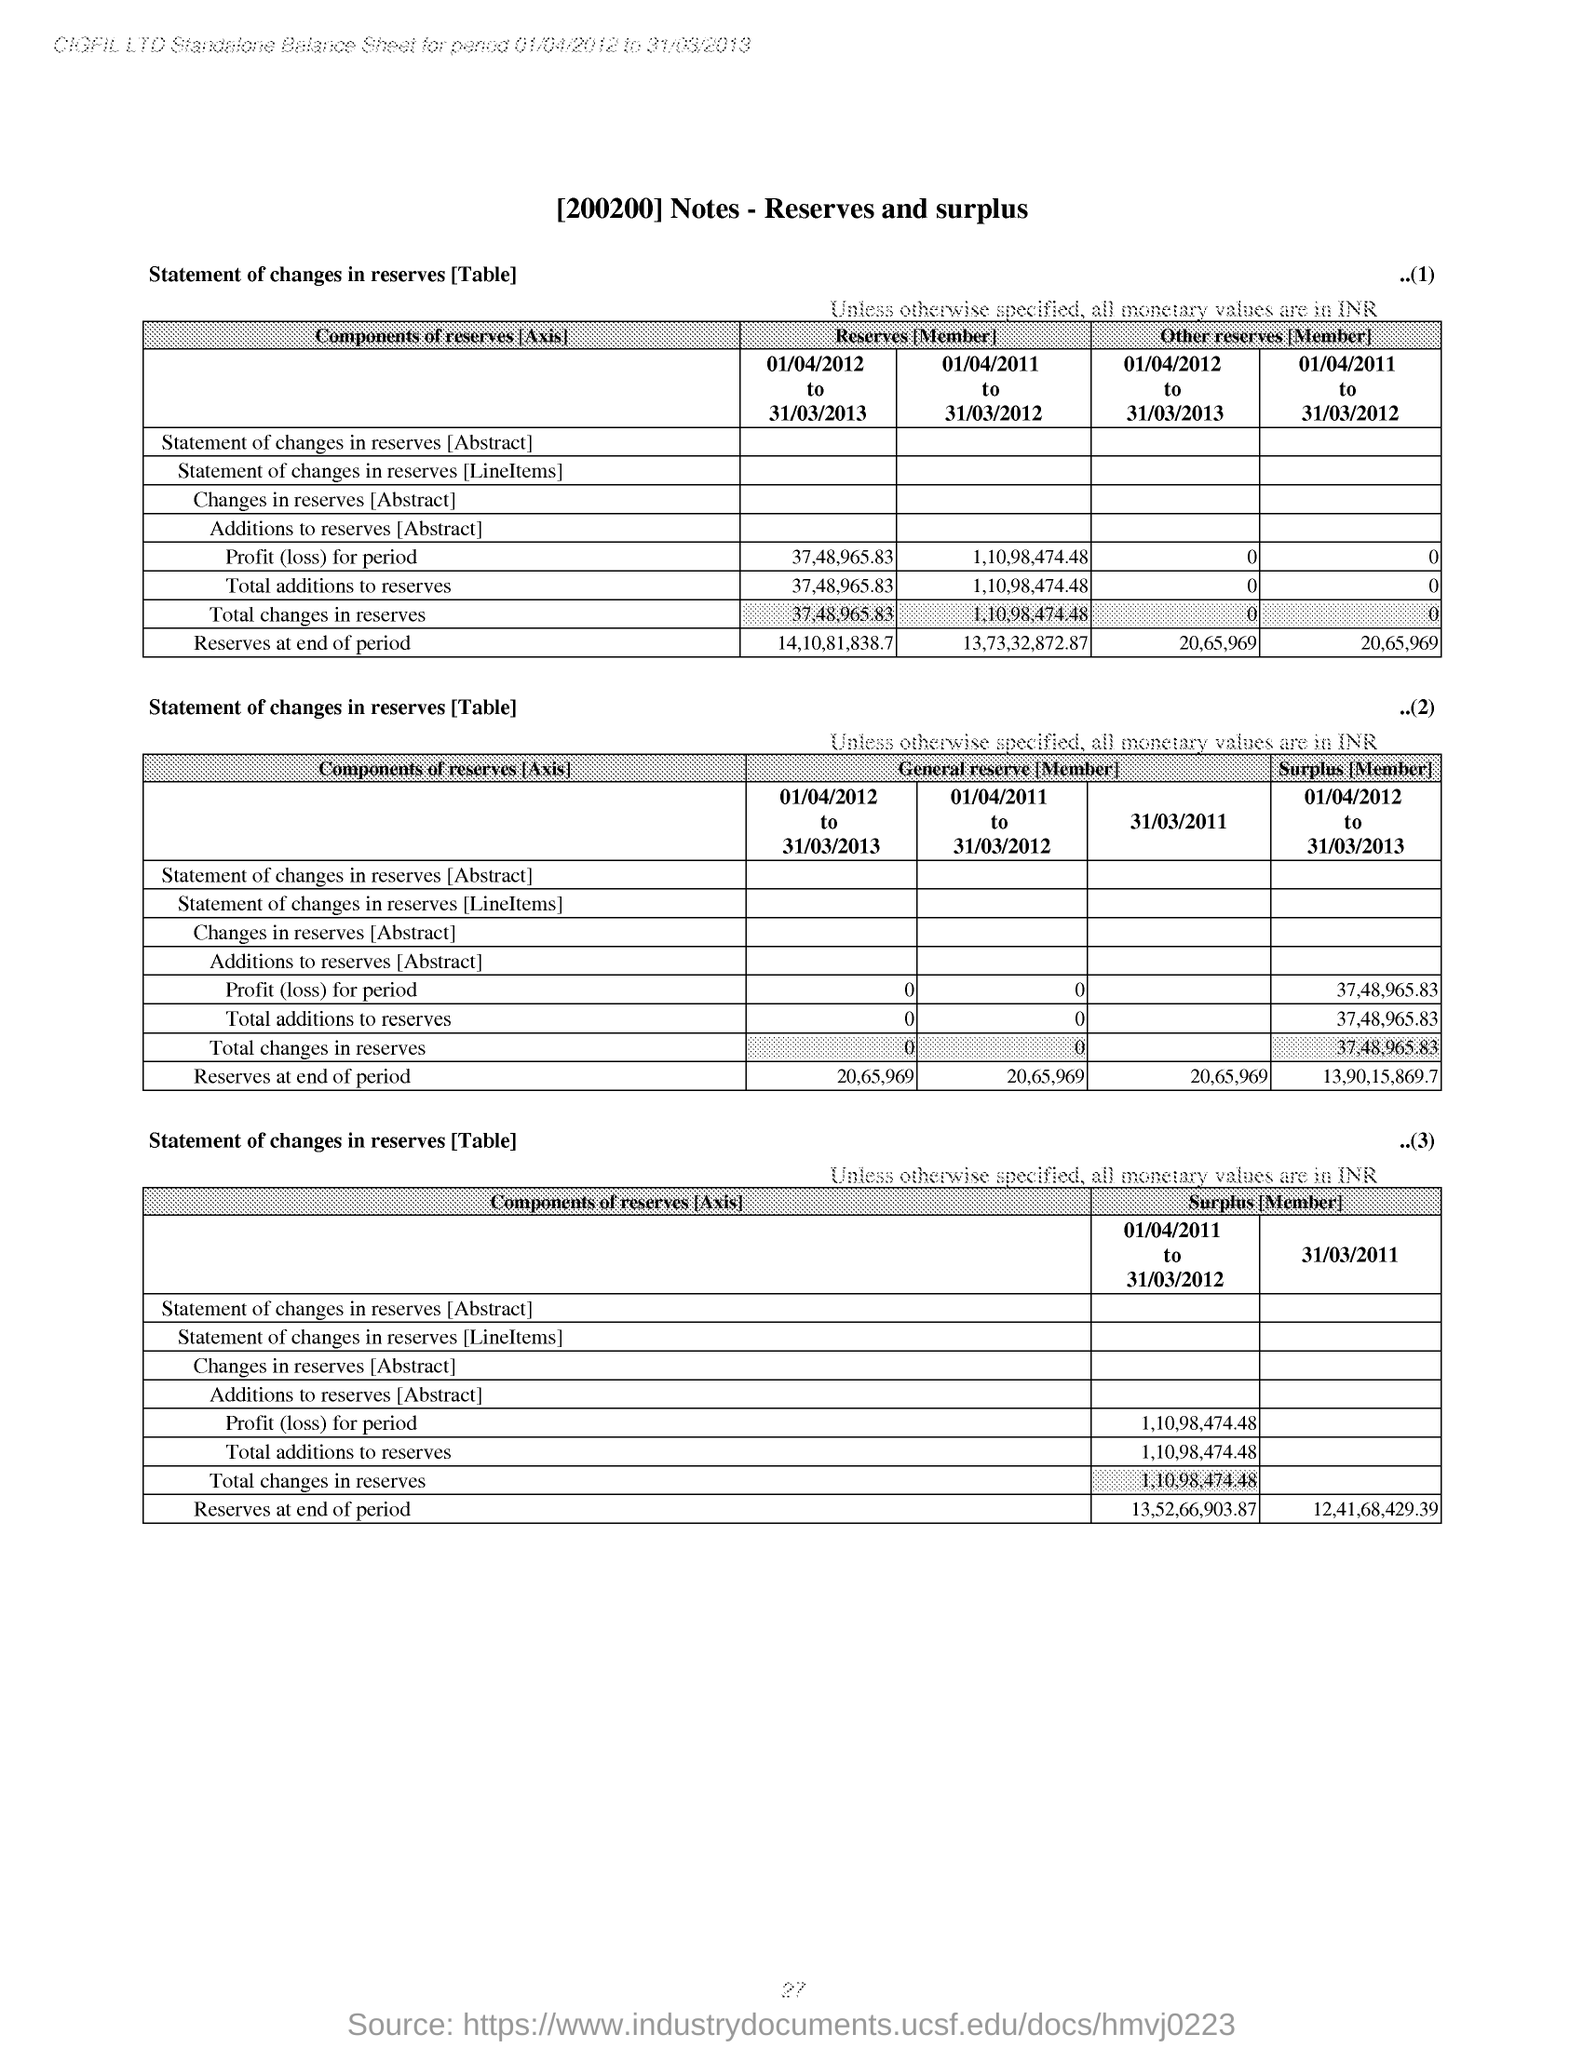Give some essential details in this illustration. The "Surplus [Member]" under the last table shows the total changes in reserves for the period of 01/04/2011 to 31/03/2012, which is equivalent to a net decrease of 1,10,98,474.48. The "Reserves at the end of period" for the period of 01/04/2012 to 31/03/2013 in table 1 is 14,10,81,838.7. The company named CIGFIL LTD., as specified in the header of the document, is... The title of the document is 'Notes - Reserves and Surplus.' 